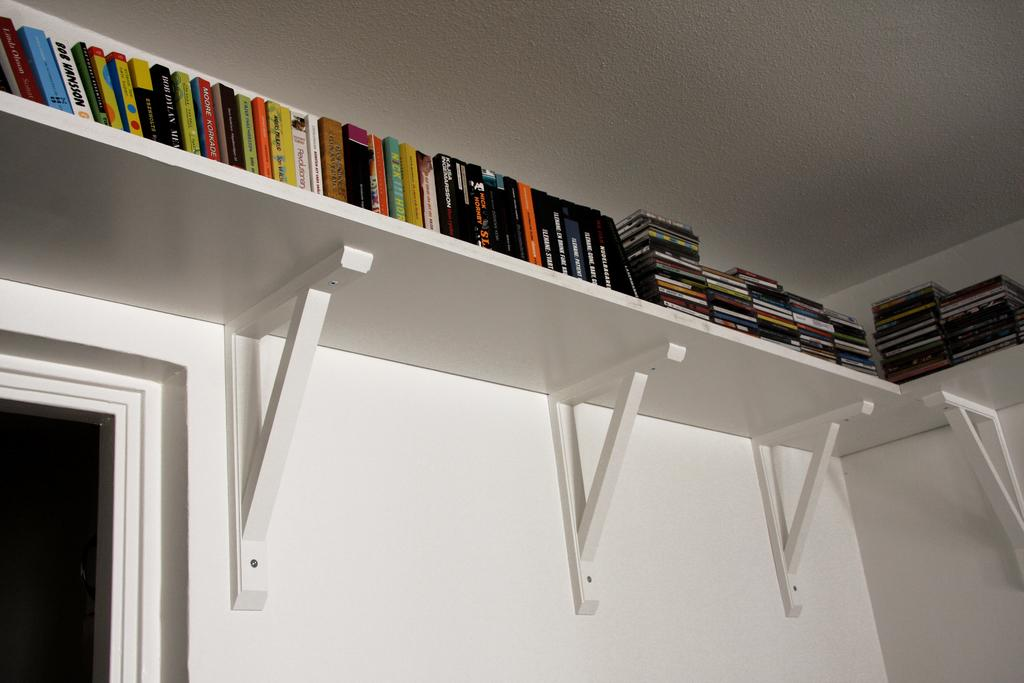What type of objects can be seen on the racks in the image? There are books on the racks in the image. Can you describe the color that is present on the bottom left side of the image? There is a black color on the bottom left side of the image. How many yaks are visible in the image? There are no yaks present in the image. What type of cat can be seen playing with the books on the racks? There is no cat present in the image, and the books are not being played with. 